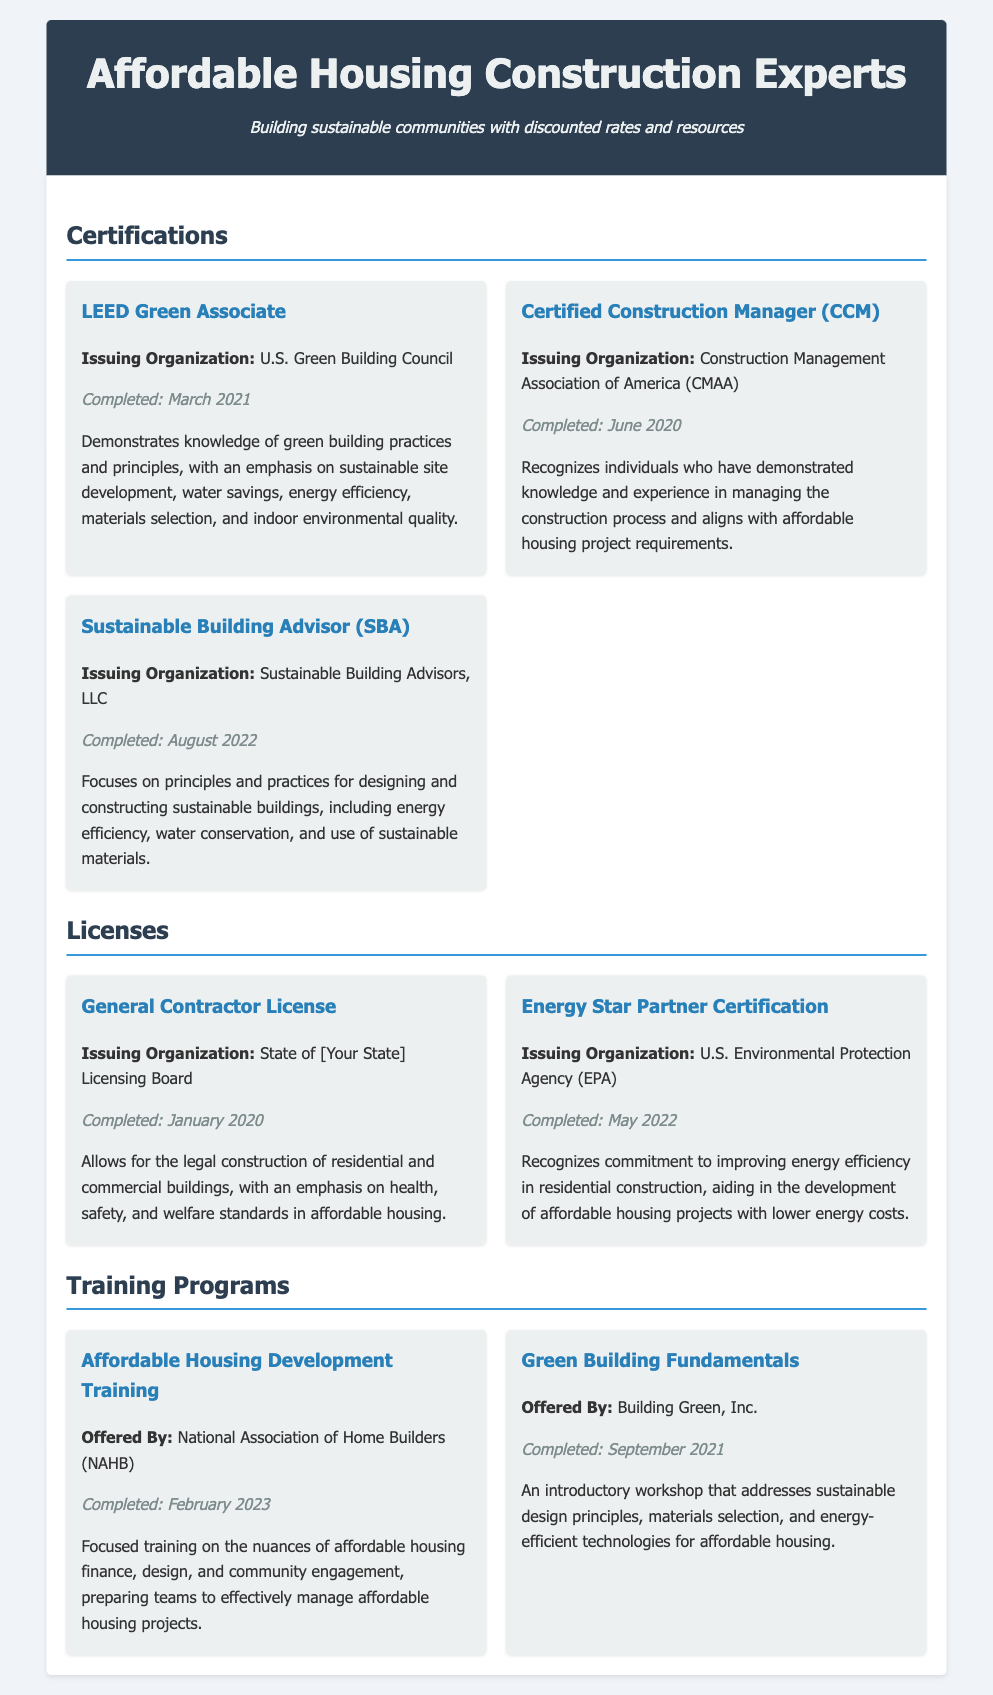what is the first certification listed? The first certification listed in the document is highlighted in the Certifications section as LEED Green Associate.
Answer: LEED Green Associate who issued the Certified Construction Manager certification? The issuing organization for the Certified Construction Manager certification is specified in the document as the Construction Management Association of America (CMAA).
Answer: Construction Management Association of America (CMAA) when was the Sustainable Building Advisor certification completed? The document states that the Sustainable Building Advisor certification was completed in August 2022, providing a specific date for this certification.
Answer: August 2022 what is the focus of the Affordable Housing Development Training program? The document describes the focus of the Affordable Housing Development Training program as training on affordable housing finance, design, and community engagement.
Answer: Affordable housing finance, design, and community engagement how many training programs are listed in the document? The document enumerates the training programs under the Training Programs section, where it mentions two training programs completed.
Answer: 2 what does the General Contractor License allow? According to the document, the General Contractor License allows for the legal construction of residential and commercial buildings.
Answer: Legal construction of residential and commercial buildings who issued the Energy Star Partner Certification? The issuing organization for the Energy Star Partner Certification is the U.S. Environmental Protection Agency (EPA), as mentioned in the Licenses section of the document.
Answer: U.S. Environmental Protection Agency (EPA) 